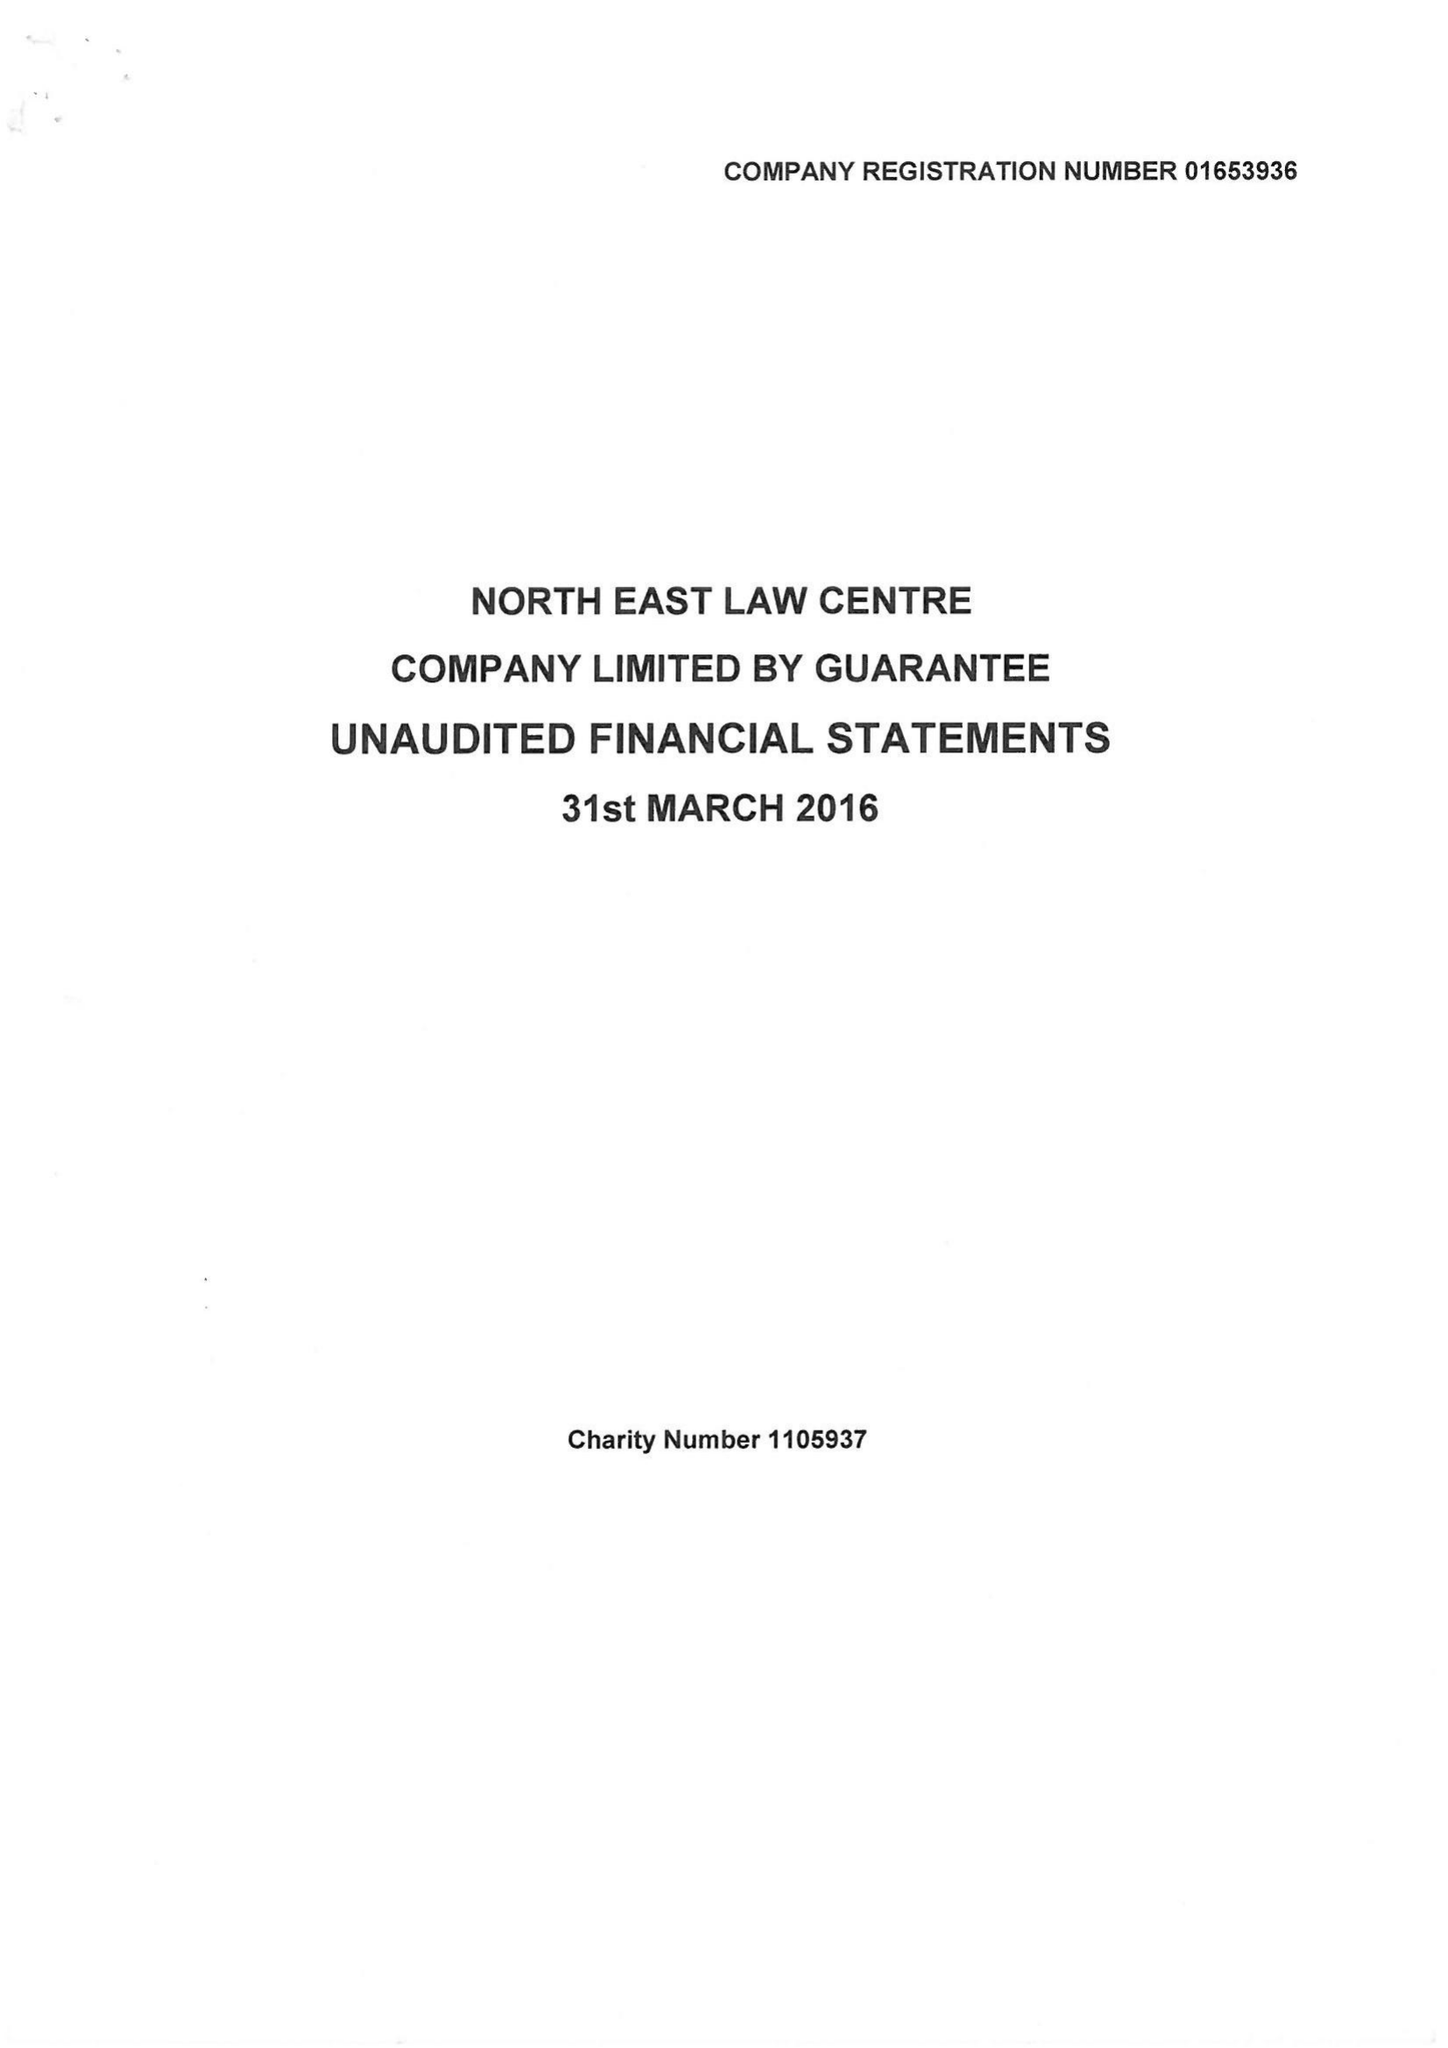What is the value for the address__postcode?
Answer the question using a single word or phrase. NE1 8XS 